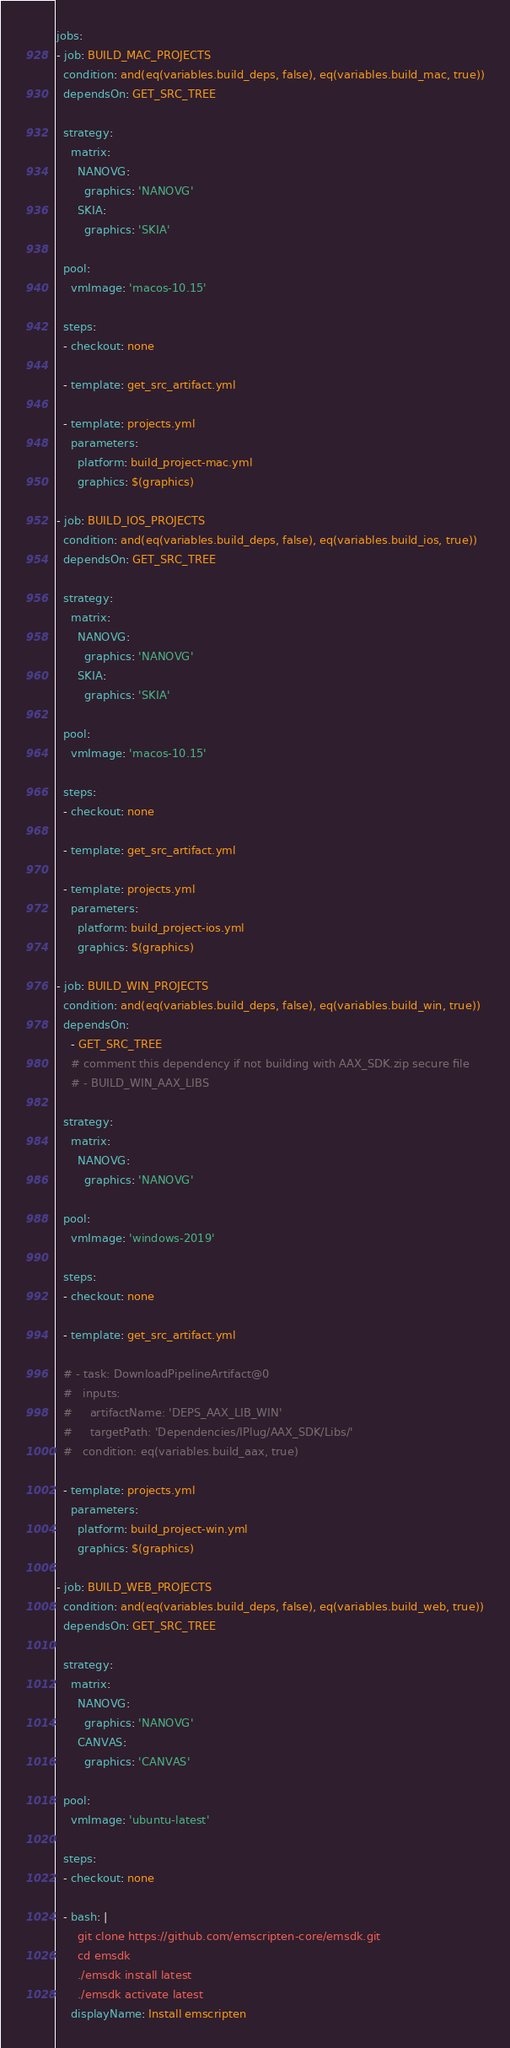Convert code to text. <code><loc_0><loc_0><loc_500><loc_500><_YAML_>jobs:
- job: BUILD_MAC_PROJECTS
  condition: and(eq(variables.build_deps, false), eq(variables.build_mac, true))
  dependsOn: GET_SRC_TREE

  strategy:
    matrix:
      NANOVG:
        graphics: 'NANOVG'
      SKIA:
        graphics: 'SKIA'

  pool:
    vmImage: 'macos-10.15'

  steps:
  - checkout: none

  - template: get_src_artifact.yml

  - template: projects.yml
    parameters:
      platform: build_project-mac.yml
      graphics: $(graphics)

- job: BUILD_IOS_PROJECTS
  condition: and(eq(variables.build_deps, false), eq(variables.build_ios, true))
  dependsOn: GET_SRC_TREE

  strategy:
    matrix:
      NANOVG:
        graphics: 'NANOVG'
      SKIA:
        graphics: 'SKIA'

  pool:
    vmImage: 'macos-10.15'

  steps:
  - checkout: none

  - template: get_src_artifact.yml

  - template: projects.yml
    parameters:
      platform: build_project-ios.yml
      graphics: $(graphics)

- job: BUILD_WIN_PROJECTS
  condition: and(eq(variables.build_deps, false), eq(variables.build_win, true))
  dependsOn:
    - GET_SRC_TREE
    # comment this dependency if not building with AAX_SDK.zip secure file
    # - BUILD_WIN_AAX_LIBS

  strategy:
    matrix:
      NANOVG:
        graphics: 'NANOVG'

  pool:
    vmImage: 'windows-2019'

  steps:
  - checkout: none

  - template: get_src_artifact.yml

  # - task: DownloadPipelineArtifact@0
  #   inputs:
  #     artifactName: 'DEPS_AAX_LIB_WIN'
  #     targetPath: 'Dependencies/IPlug/AAX_SDK/Libs/'
  #   condition: eq(variables.build_aax, true)

  - template: projects.yml
    parameters:
      platform: build_project-win.yml
      graphics: $(graphics)

- job: BUILD_WEB_PROJECTS
  condition: and(eq(variables.build_deps, false), eq(variables.build_web, true))
  dependsOn: GET_SRC_TREE

  strategy:
    matrix:
      NANOVG:
        graphics: 'NANOVG'
      CANVAS:
        graphics: 'CANVAS'

  pool:
    vmImage: 'ubuntu-latest'

  steps:
  - checkout: none

  - bash: |
      git clone https://github.com/emscripten-core/emsdk.git
      cd emsdk
      ./emsdk install latest 
      ./emsdk activate latest
    displayName: Install emscripten
</code> 